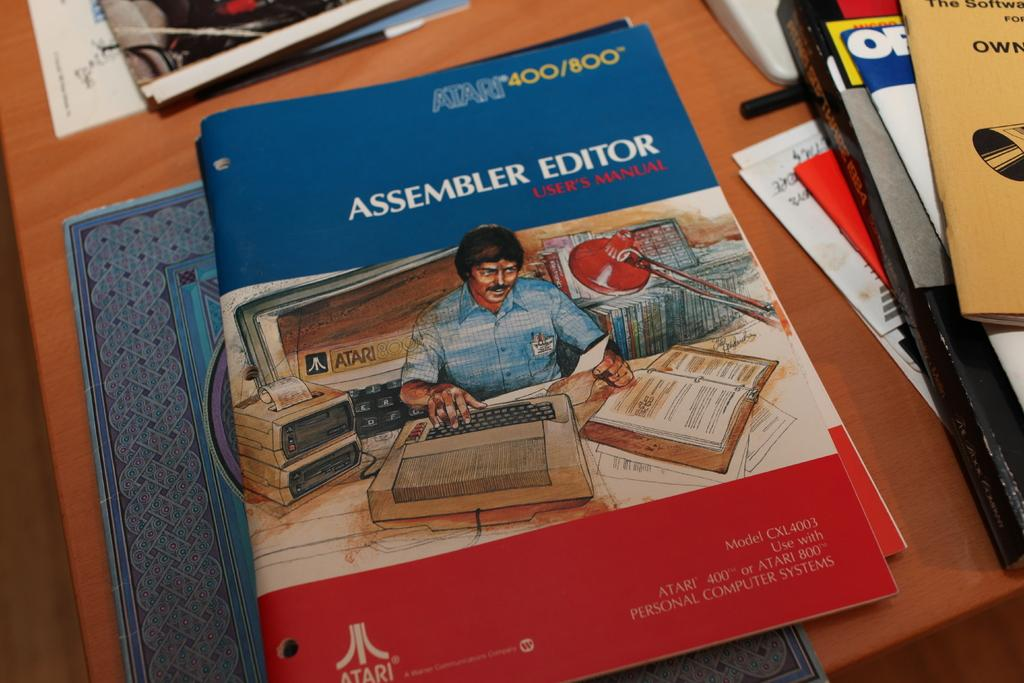<image>
Relay a brief, clear account of the picture shown. A group of books with the only one being see-able being a user manual. 